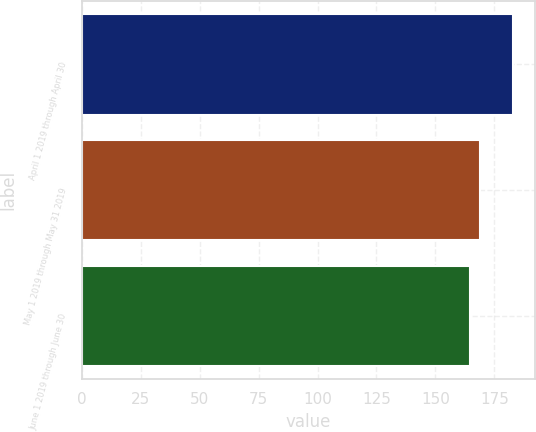Convert chart to OTSL. <chart><loc_0><loc_0><loc_500><loc_500><bar_chart><fcel>April 1 2019 through April 30<fcel>May 1 2019 through May 31 2019<fcel>June 1 2019 through June 30<nl><fcel>182.97<fcel>168.89<fcel>164.5<nl></chart> 